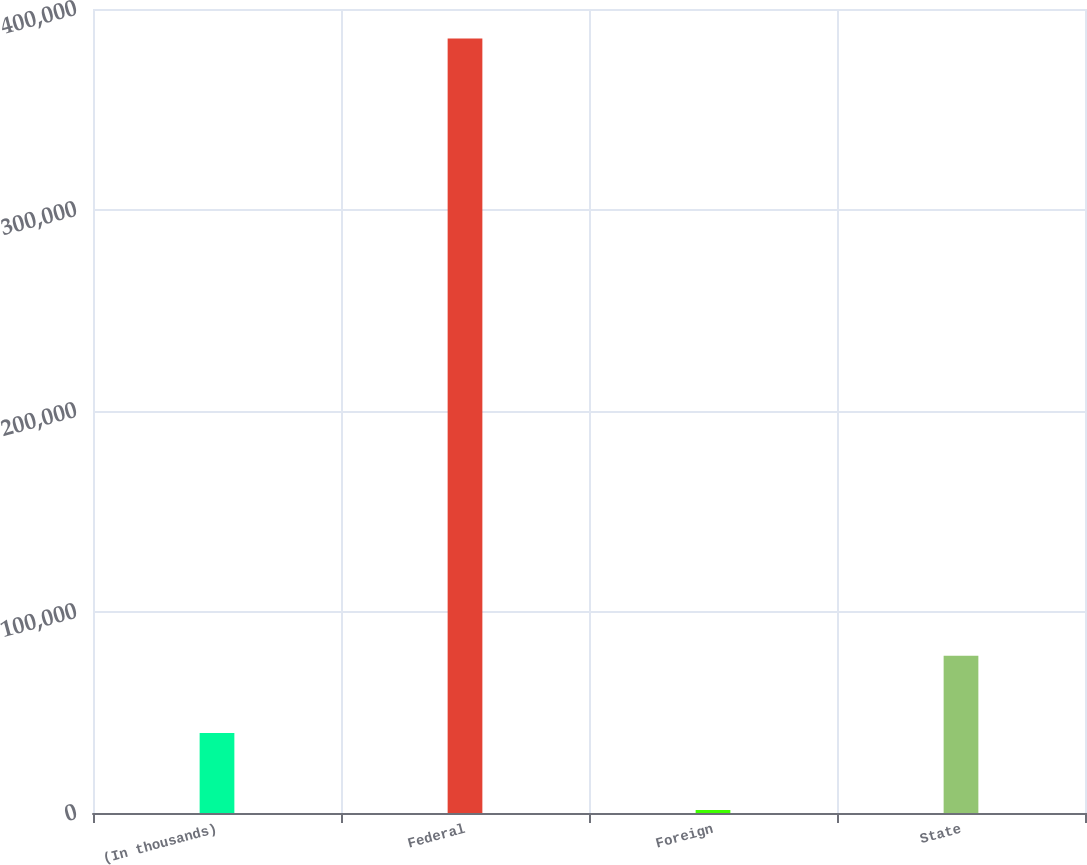Convert chart to OTSL. <chart><loc_0><loc_0><loc_500><loc_500><bar_chart><fcel>(In thousands)<fcel>Federal<fcel>Foreign<fcel>State<nl><fcel>39831.8<fcel>385277<fcel>1449<fcel>78214.6<nl></chart> 